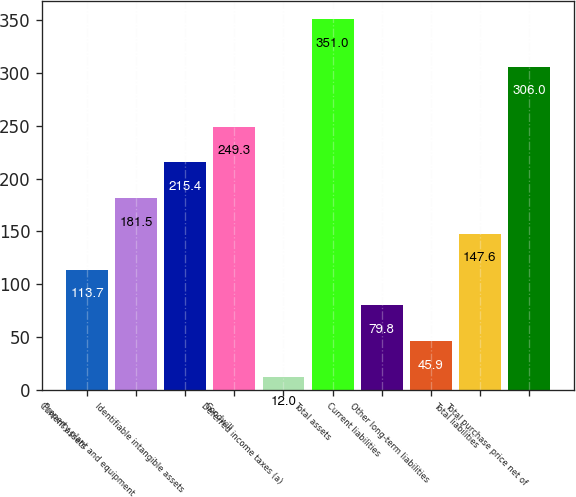Convert chart to OTSL. <chart><loc_0><loc_0><loc_500><loc_500><bar_chart><fcel>Current assets<fcel>Property plant and equipment<fcel>Identifiable intangible assets<fcel>Goodwill<fcel>Deferred income taxes (a)<fcel>Total assets<fcel>Current liabilities<fcel>Other long-term liabilities<fcel>Total liabilities<fcel>Total purchase price net of<nl><fcel>113.7<fcel>181.5<fcel>215.4<fcel>249.3<fcel>12<fcel>351<fcel>79.8<fcel>45.9<fcel>147.6<fcel>306<nl></chart> 